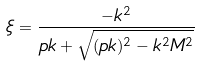<formula> <loc_0><loc_0><loc_500><loc_500>\xi = \frac { - k ^ { 2 } } { p k + \sqrt { ( p k ) ^ { 2 } - k ^ { 2 } M ^ { 2 } } }</formula> 